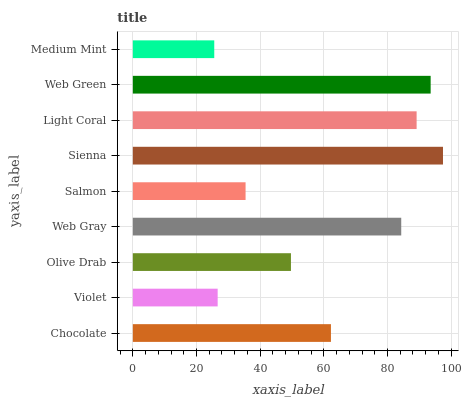Is Medium Mint the minimum?
Answer yes or no. Yes. Is Sienna the maximum?
Answer yes or no. Yes. Is Violet the minimum?
Answer yes or no. No. Is Violet the maximum?
Answer yes or no. No. Is Chocolate greater than Violet?
Answer yes or no. Yes. Is Violet less than Chocolate?
Answer yes or no. Yes. Is Violet greater than Chocolate?
Answer yes or no. No. Is Chocolate less than Violet?
Answer yes or no. No. Is Chocolate the high median?
Answer yes or no. Yes. Is Chocolate the low median?
Answer yes or no. Yes. Is Olive Drab the high median?
Answer yes or no. No. Is Web Green the low median?
Answer yes or no. No. 